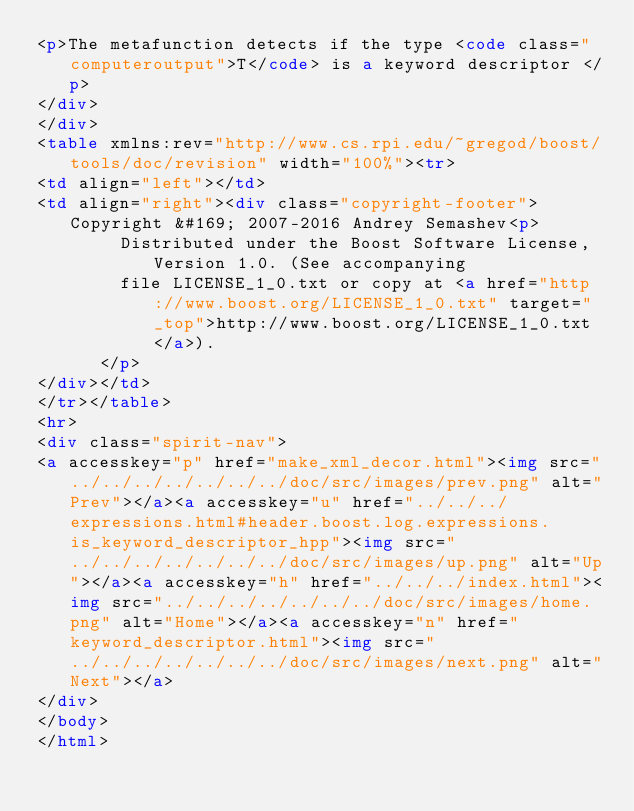<code> <loc_0><loc_0><loc_500><loc_500><_HTML_><p>The metafunction detects if the type <code class="computeroutput">T</code> is a keyword descriptor </p>
</div>
</div>
<table xmlns:rev="http://www.cs.rpi.edu/~gregod/boost/tools/doc/revision" width="100%"><tr>
<td align="left"></td>
<td align="right"><div class="copyright-footer">Copyright &#169; 2007-2016 Andrey Semashev<p>
        Distributed under the Boost Software License, Version 1.0. (See accompanying
        file LICENSE_1_0.txt or copy at <a href="http://www.boost.org/LICENSE_1_0.txt" target="_top">http://www.boost.org/LICENSE_1_0.txt</a>).
      </p>
</div></td>
</tr></table>
<hr>
<div class="spirit-nav">
<a accesskey="p" href="make_xml_decor.html"><img src="../../../../../../../doc/src/images/prev.png" alt="Prev"></a><a accesskey="u" href="../../../expressions.html#header.boost.log.expressions.is_keyword_descriptor_hpp"><img src="../../../../../../../doc/src/images/up.png" alt="Up"></a><a accesskey="h" href="../../../index.html"><img src="../../../../../../../doc/src/images/home.png" alt="Home"></a><a accesskey="n" href="keyword_descriptor.html"><img src="../../../../../../../doc/src/images/next.png" alt="Next"></a>
</div>
</body>
</html>
</code> 